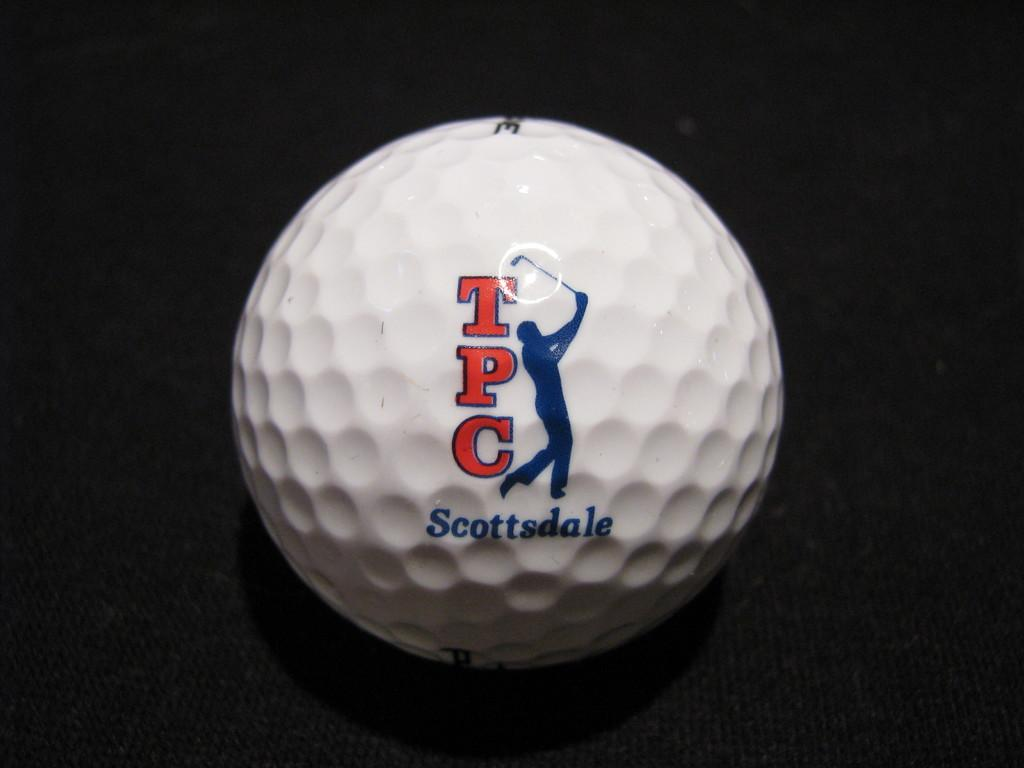<image>
Give a short and clear explanation of the subsequent image. A white golf ball with a golfer image and written on the ball is TPC and Scottdale. 